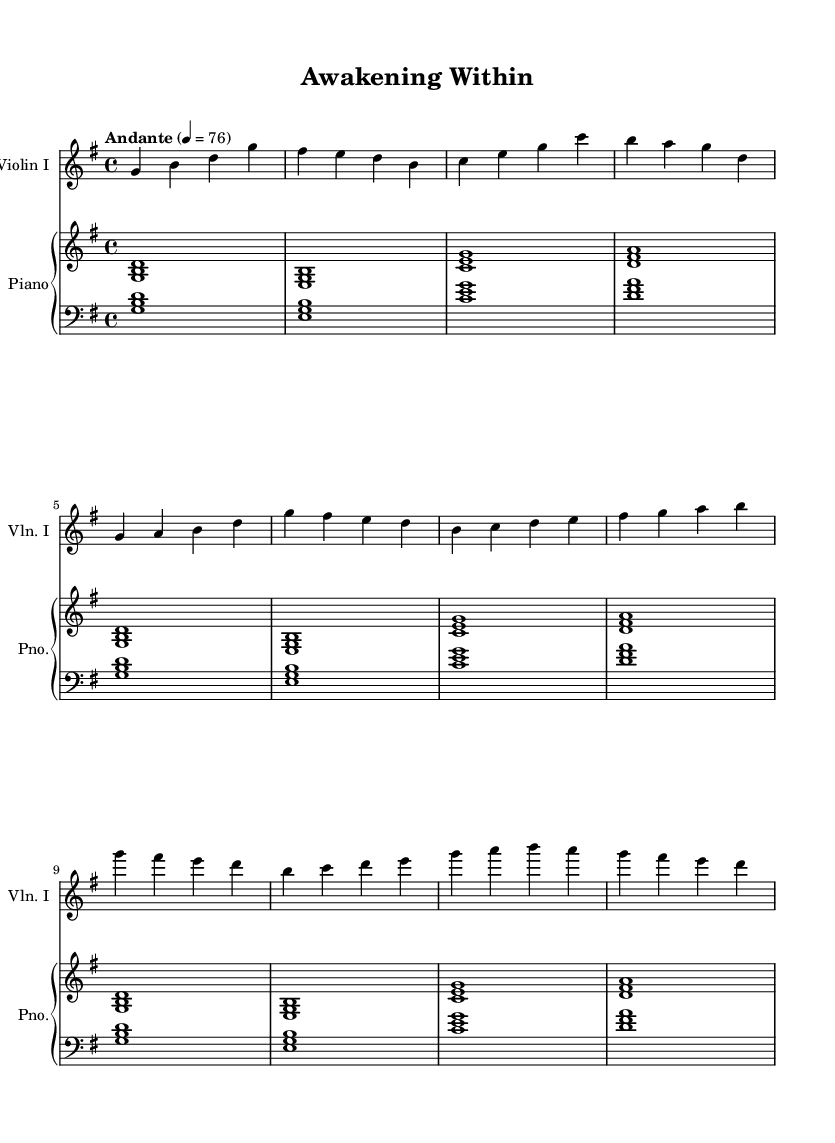What is the key signature of this music? The key signature is G major, which has one sharp (F#).
Answer: G major What is the time signature of this music? The time signature is 4/4, which means there are four beats in each measure.
Answer: 4/4 What is the tempo marking of this music? The tempo marking is "Andante," indicating a moderate walking pace.
Answer: Andante How many measures are in the intro section? The intro section consists of 4 measures, as indicated before the verse begins.
Answer: 4 measures What instruments are included in this score? The score includes Violin I and Piano, as indicated in the staff names.
Answer: Violin I and Piano What dynamic marking is likely implied in the section "Chorus"? The dynamic marking is not explicitly given, but uplifting soundtracks often suggest a crescendo, creating a feeling of climax.
Answer: Crescendo (implied) Why is this piece categorized as an orchestral soundtrack? This piece has orchestral elements like strings and piano, emphasizing emotional themes and storytelling, suitable for film or scenes of personal growth.
Answer: Orchestral elements 